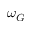Convert formula to latex. <formula><loc_0><loc_0><loc_500><loc_500>\omega _ { G }</formula> 